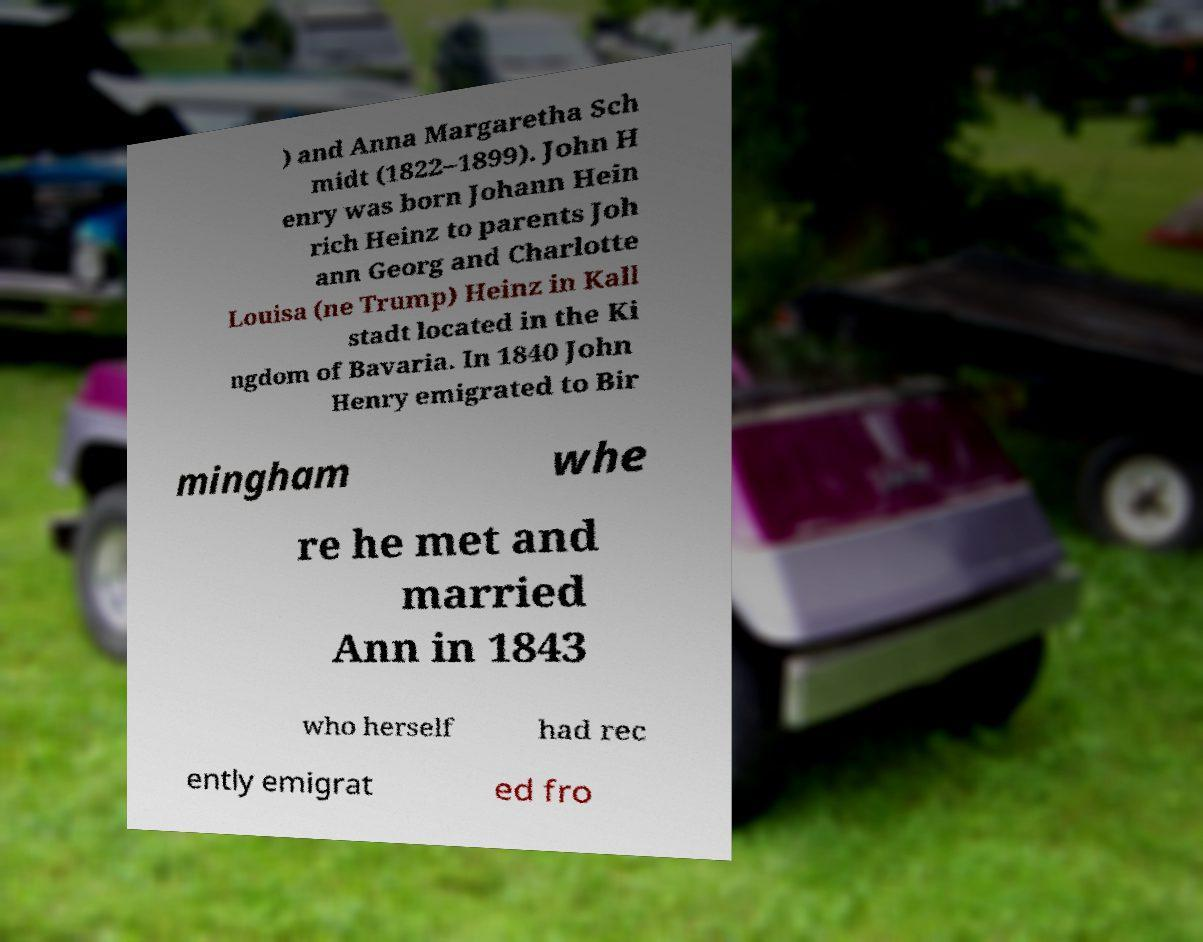Can you accurately transcribe the text from the provided image for me? ) and Anna Margaretha Sch midt (1822–1899). John H enry was born Johann Hein rich Heinz to parents Joh ann Georg and Charlotte Louisa (ne Trump) Heinz in Kall stadt located in the Ki ngdom of Bavaria. In 1840 John Henry emigrated to Bir mingham whe re he met and married Ann in 1843 who herself had rec ently emigrat ed fro 